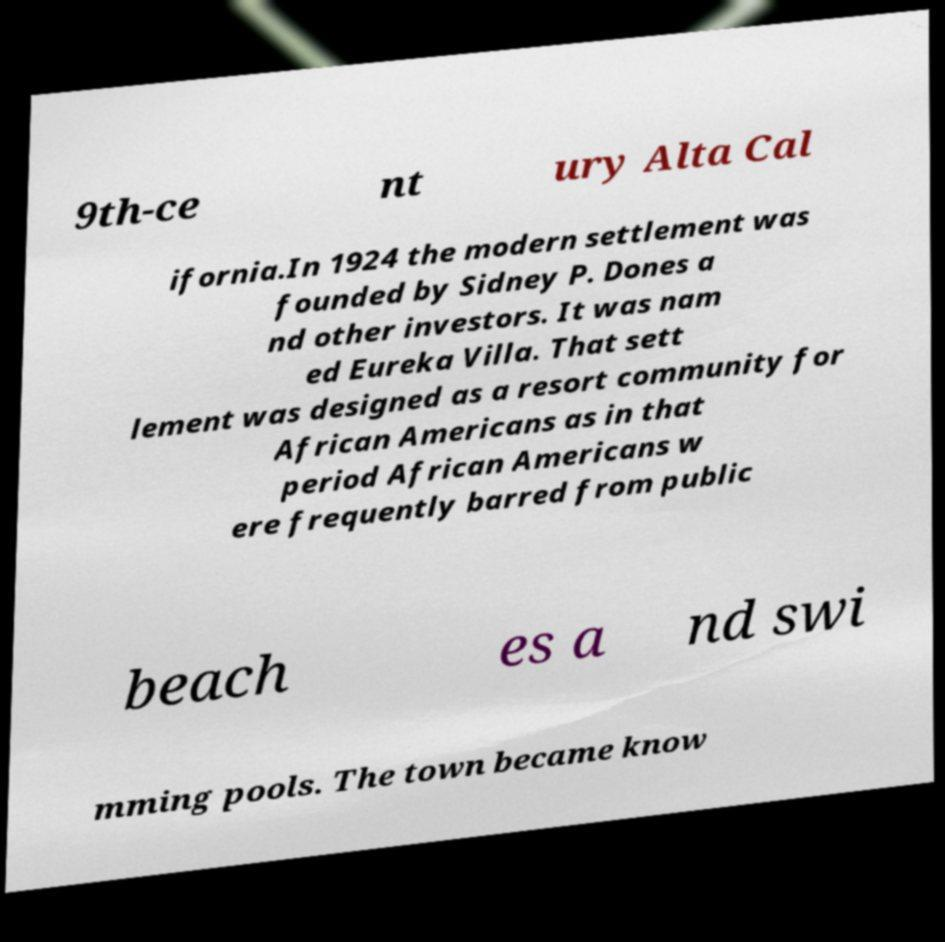Please read and relay the text visible in this image. What does it say? 9th-ce nt ury Alta Cal ifornia.In 1924 the modern settlement was founded by Sidney P. Dones a nd other investors. It was nam ed Eureka Villa. That sett lement was designed as a resort community for African Americans as in that period African Americans w ere frequently barred from public beach es a nd swi mming pools. The town became know 